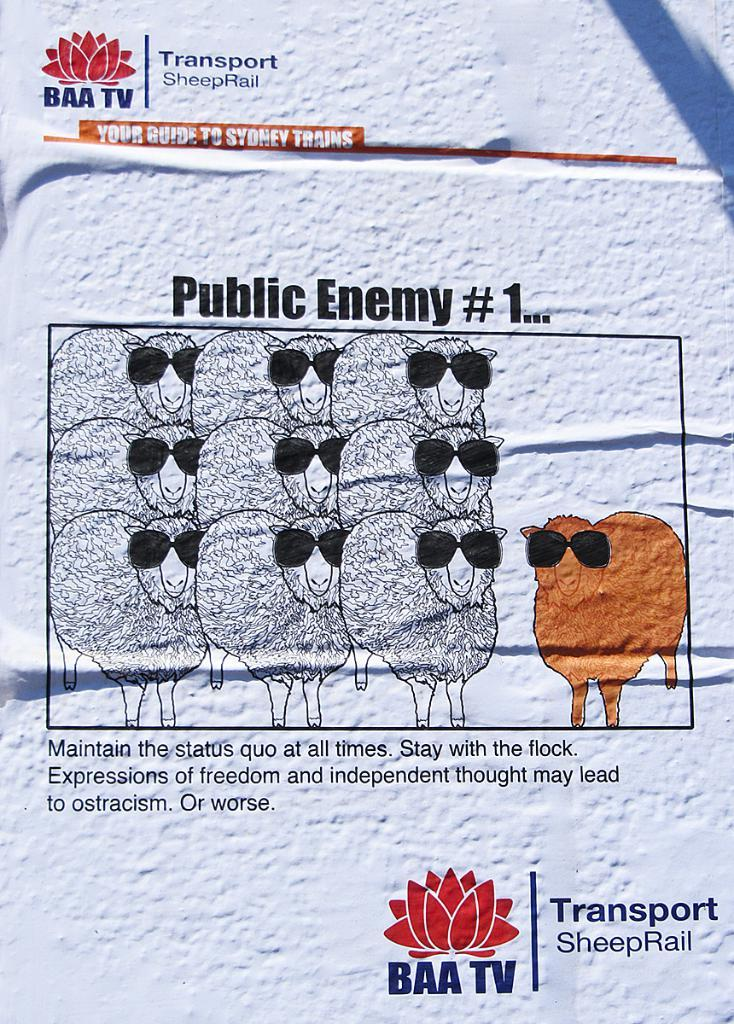What is on the wall in the image? There is a poster on the wall in the image. What can be seen in the poster? The poster contains images of sheep. Is there any text on the poster? Yes, there is text on the poster. Can you see a carriage being pulled by the sheep in the poster? No, there is no carriage or any indication of a fight in the poster; it only contains images of sheep and text. 